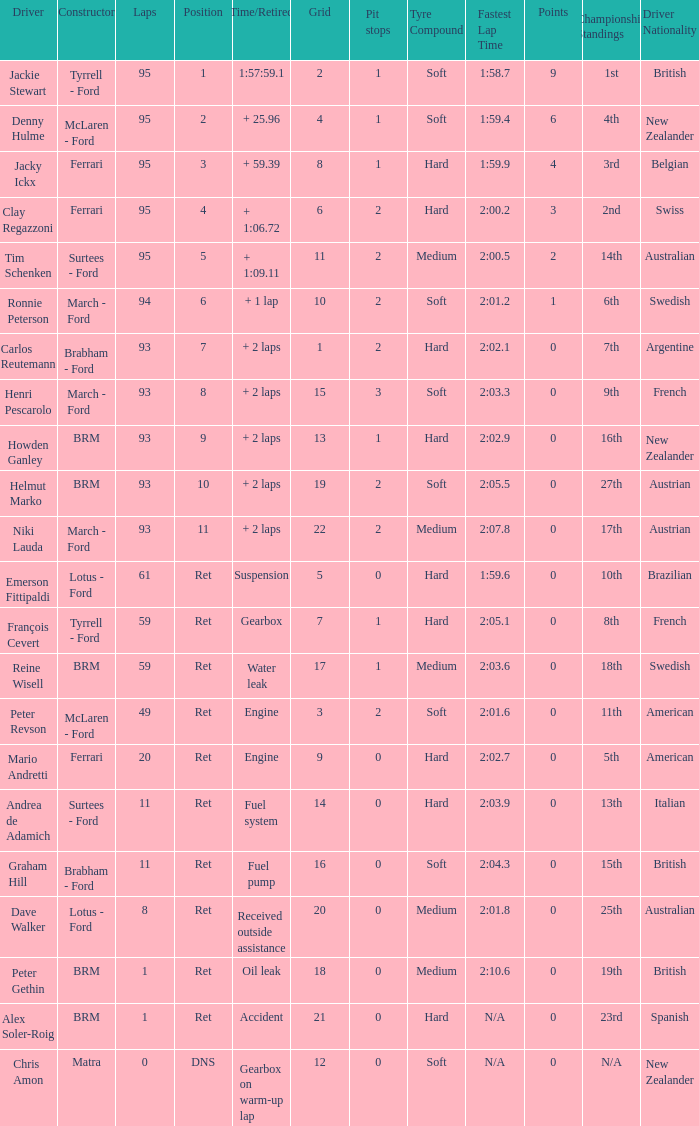Could you parse the entire table? {'header': ['Driver', 'Constructor', 'Laps', 'Position', 'Time/Retired', 'Grid', 'Pit stops', 'Tyre Compound', 'Fastest Lap Time', 'Points', 'Championship Standings', 'Driver Nationality'], 'rows': [['Jackie Stewart', 'Tyrrell - Ford', '95', '1', '1:57:59.1', '2', '1', 'Soft', '1:58.7', '9', '1st', 'British'], ['Denny Hulme', 'McLaren - Ford', '95', '2', '+ 25.96', '4', '1', 'Soft', '1:59.4', '6', '4th', 'New Zealander'], ['Jacky Ickx', 'Ferrari', '95', '3', '+ 59.39', '8', '1', 'Hard', '1:59.9', '4', '3rd', 'Belgian'], ['Clay Regazzoni', 'Ferrari', '95', '4', '+ 1:06.72', '6', '2', 'Hard', '2:00.2', '3', '2nd', 'Swiss'], ['Tim Schenken', 'Surtees - Ford', '95', '5', '+ 1:09.11', '11', '2', 'Medium', '2:00.5', '2', '14th', 'Australian'], ['Ronnie Peterson', 'March - Ford', '94', '6', '+ 1 lap', '10', '2', 'Soft', '2:01.2', '1', '6th', 'Swedish'], ['Carlos Reutemann', 'Brabham - Ford', '93', '7', '+ 2 laps', '1', '2', 'Hard', '2:02.1', '0', '7th', 'Argentine'], ['Henri Pescarolo', 'March - Ford', '93', '8', '+ 2 laps', '15', '3', 'Soft', '2:03.3', '0', '9th', 'French'], ['Howden Ganley', 'BRM', '93', '9', '+ 2 laps', '13', '1', 'Hard', '2:02.9', '0', '16th', 'New Zealander'], ['Helmut Marko', 'BRM', '93', '10', '+ 2 laps', '19', '2', 'Soft', '2:05.5', '0', '27th', 'Austrian'], ['Niki Lauda', 'March - Ford', '93', '11', '+ 2 laps', '22', '2', 'Medium', '2:07.8', '0', '17th', 'Austrian'], ['Emerson Fittipaldi', 'Lotus - Ford', '61', 'Ret', 'Suspension', '5', '0', 'Hard', '1:59.6', '0', '10th', 'Brazilian'], ['François Cevert', 'Tyrrell - Ford', '59', 'Ret', 'Gearbox', '7', '1', 'Hard', '2:05.1', '0', '8th', 'French'], ['Reine Wisell', 'BRM', '59', 'Ret', 'Water leak', '17', '1', 'Medium', '2:03.6', '0', '18th', 'Swedish'], ['Peter Revson', 'McLaren - Ford', '49', 'Ret', 'Engine', '3', '2', 'Soft', '2:01.6', '0', '11th', 'American'], ['Mario Andretti', 'Ferrari', '20', 'Ret', 'Engine', '9', '0', 'Hard', '2:02.7', '0', '5th', 'American'], ['Andrea de Adamich', 'Surtees - Ford', '11', 'Ret', 'Fuel system', '14', '0', 'Hard', '2:03.9', '0', '13th', 'Italian'], ['Graham Hill', 'Brabham - Ford', '11', 'Ret', 'Fuel pump', '16', '0', 'Soft', '2:04.3', '0', '15th', 'British'], ['Dave Walker', 'Lotus - Ford', '8', 'Ret', 'Received outside assistance', '20', '0', 'Medium', '2:01.8', '0', '25th', 'Australian'], ['Peter Gethin', 'BRM', '1', 'Ret', 'Oil leak', '18', '0', 'Medium', '2:10.6', '0', '19th', 'British'], ['Alex Soler-Roig', 'BRM', '1', 'Ret', 'Accident', '21', '0', 'Hard', 'N/A', '0', '23rd', 'Spanish'], ['Chris Amon', 'Matra', '0', 'DNS', 'Gearbox on warm-up lap', '12', '0', 'Soft', 'N/A', '0', 'N/A', 'New Zealander']]} What is the lowest grid with matra as constructor? 12.0. 